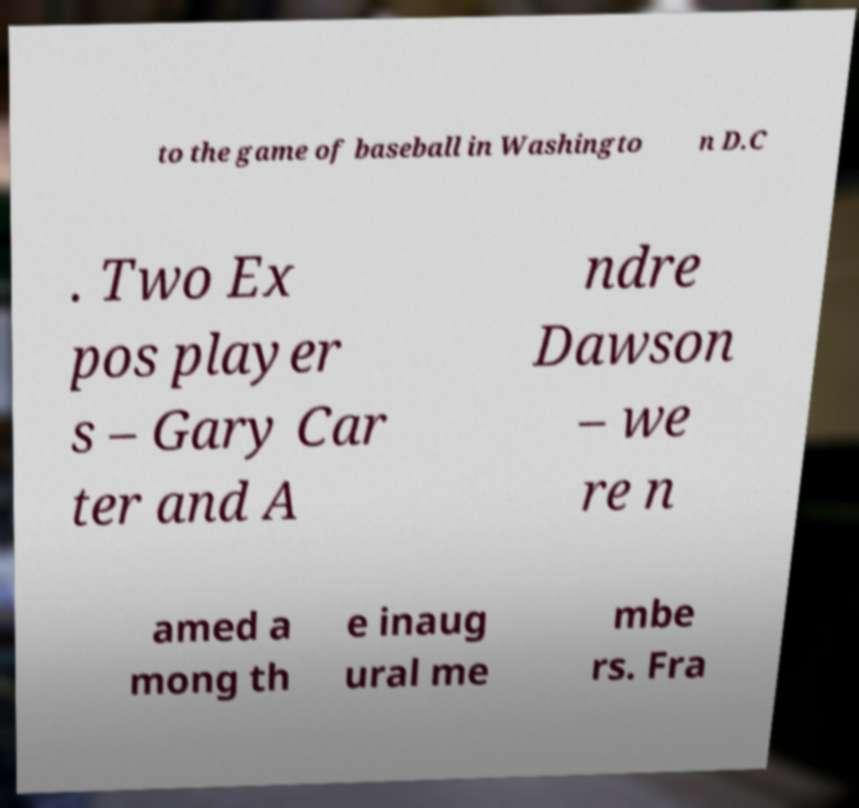Could you assist in decoding the text presented in this image and type it out clearly? to the game of baseball in Washingto n D.C . Two Ex pos player s – Gary Car ter and A ndre Dawson – we re n amed a mong th e inaug ural me mbe rs. Fra 